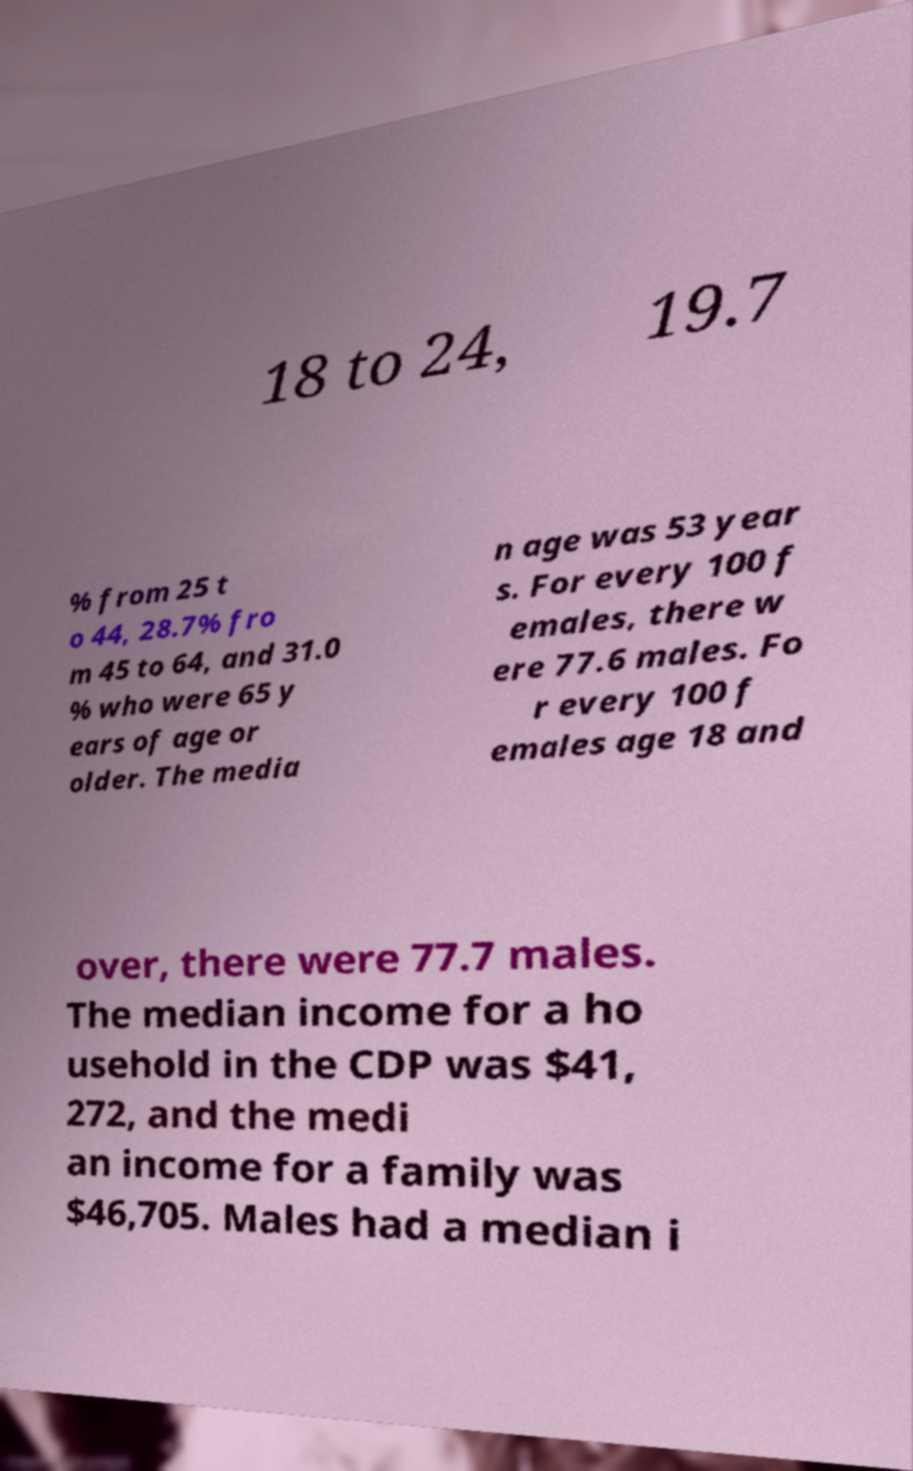Please read and relay the text visible in this image. What does it say? 18 to 24, 19.7 % from 25 t o 44, 28.7% fro m 45 to 64, and 31.0 % who were 65 y ears of age or older. The media n age was 53 year s. For every 100 f emales, there w ere 77.6 males. Fo r every 100 f emales age 18 and over, there were 77.7 males. The median income for a ho usehold in the CDP was $41, 272, and the medi an income for a family was $46,705. Males had a median i 